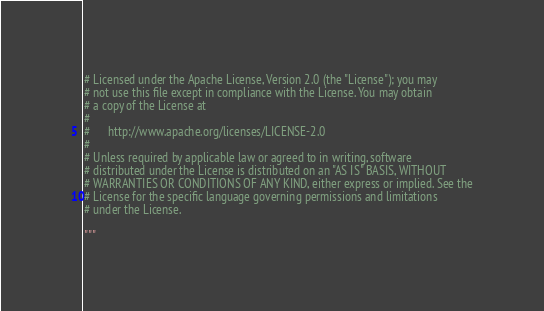Convert code to text. <code><loc_0><loc_0><loc_500><loc_500><_Python_># Licensed under the Apache License, Version 2.0 (the "License"); you may
# not use this file except in compliance with the License. You may obtain
# a copy of the License at
#
#      http://www.apache.org/licenses/LICENSE-2.0
#
# Unless required by applicable law or agreed to in writing, software
# distributed under the License is distributed on an "AS IS" BASIS, WITHOUT
# WARRANTIES OR CONDITIONS OF ANY KIND, either express or implied. See the
# License for the specific language governing permissions and limitations
# under the License.

"""</code> 